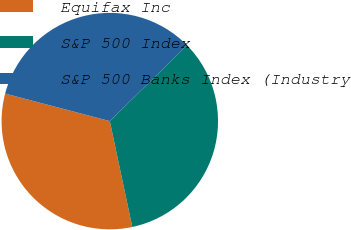Convert chart to OTSL. <chart><loc_0><loc_0><loc_500><loc_500><pie_chart><fcel>Equifax Inc<fcel>S&P 500 Index<fcel>S&P 500 Banks Index (Industry<nl><fcel>32.43%<fcel>34.02%<fcel>33.56%<nl></chart> 